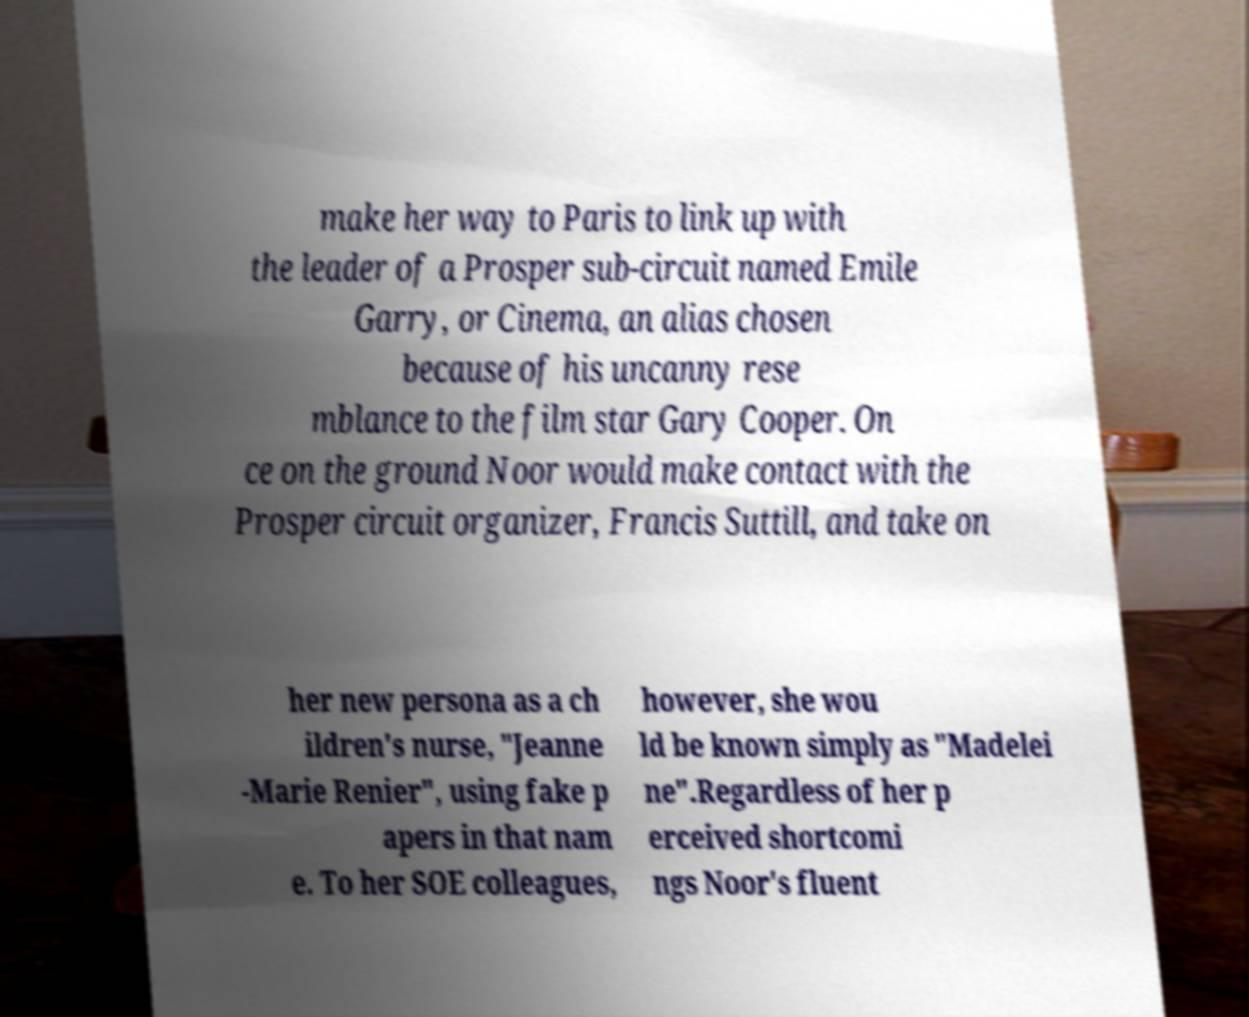I need the written content from this picture converted into text. Can you do that? make her way to Paris to link up with the leader of a Prosper sub-circuit named Emile Garry, or Cinema, an alias chosen because of his uncanny rese mblance to the film star Gary Cooper. On ce on the ground Noor would make contact with the Prosper circuit organizer, Francis Suttill, and take on her new persona as a ch ildren's nurse, "Jeanne -Marie Renier", using fake p apers in that nam e. To her SOE colleagues, however, she wou ld be known simply as "Madelei ne".Regardless of her p erceived shortcomi ngs Noor's fluent 